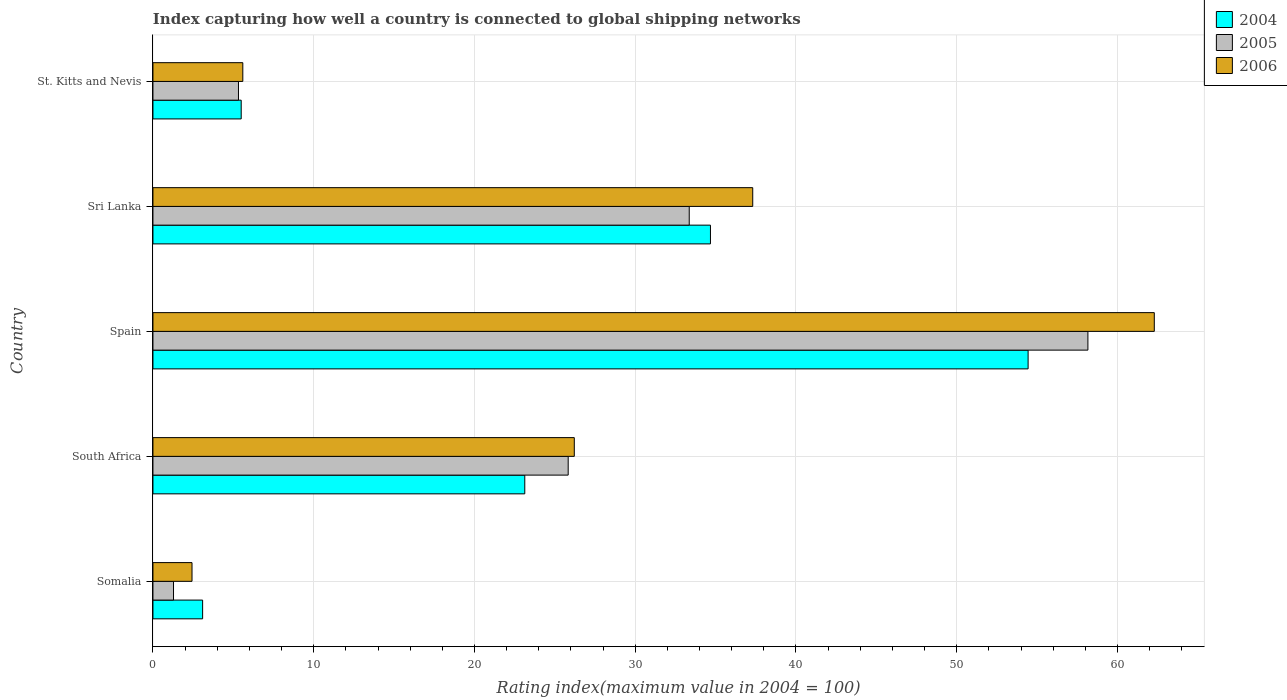Are the number of bars on each tick of the Y-axis equal?
Your response must be concise. Yes. What is the label of the 5th group of bars from the top?
Your response must be concise. Somalia. What is the rating index in 2006 in St. Kitts and Nevis?
Your answer should be very brief. 5.59. Across all countries, what is the maximum rating index in 2006?
Provide a short and direct response. 62.29. Across all countries, what is the minimum rating index in 2005?
Provide a short and direct response. 1.28. In which country was the rating index in 2006 minimum?
Your answer should be very brief. Somalia. What is the total rating index in 2005 in the graph?
Make the answer very short. 123.95. What is the difference between the rating index in 2005 in Spain and that in St. Kitts and Nevis?
Give a very brief answer. 52.84. What is the difference between the rating index in 2004 in Sri Lanka and the rating index in 2006 in South Africa?
Keep it short and to the point. 8.47. What is the average rating index in 2005 per country?
Your answer should be very brief. 24.79. What is the difference between the rating index in 2004 and rating index in 2005 in St. Kitts and Nevis?
Ensure brevity in your answer.  0.17. What is the ratio of the rating index in 2006 in South Africa to that in Sri Lanka?
Ensure brevity in your answer.  0.7. Is the rating index in 2004 in Spain less than that in Sri Lanka?
Offer a very short reply. No. What is the difference between the highest and the second highest rating index in 2004?
Offer a very short reply. 19.76. What is the difference between the highest and the lowest rating index in 2006?
Provide a short and direct response. 59.86. What does the 3rd bar from the top in South Africa represents?
Your answer should be very brief. 2004. How many bars are there?
Your answer should be very brief. 15. Are all the bars in the graph horizontal?
Your response must be concise. Yes. How many legend labels are there?
Offer a terse response. 3. How are the legend labels stacked?
Your answer should be very brief. Vertical. What is the title of the graph?
Your answer should be very brief. Index capturing how well a country is connected to global shipping networks. Does "1969" appear as one of the legend labels in the graph?
Ensure brevity in your answer.  No. What is the label or title of the X-axis?
Make the answer very short. Rating index(maximum value in 2004 = 100). What is the Rating index(maximum value in 2004 = 100) in 2004 in Somalia?
Your response must be concise. 3.09. What is the Rating index(maximum value in 2004 = 100) in 2005 in Somalia?
Ensure brevity in your answer.  1.28. What is the Rating index(maximum value in 2004 = 100) in 2006 in Somalia?
Give a very brief answer. 2.43. What is the Rating index(maximum value in 2004 = 100) of 2004 in South Africa?
Make the answer very short. 23.13. What is the Rating index(maximum value in 2004 = 100) in 2005 in South Africa?
Your response must be concise. 25.83. What is the Rating index(maximum value in 2004 = 100) in 2006 in South Africa?
Offer a terse response. 26.21. What is the Rating index(maximum value in 2004 = 100) of 2004 in Spain?
Give a very brief answer. 54.44. What is the Rating index(maximum value in 2004 = 100) of 2005 in Spain?
Your answer should be very brief. 58.16. What is the Rating index(maximum value in 2004 = 100) in 2006 in Spain?
Ensure brevity in your answer.  62.29. What is the Rating index(maximum value in 2004 = 100) of 2004 in Sri Lanka?
Your answer should be very brief. 34.68. What is the Rating index(maximum value in 2004 = 100) of 2005 in Sri Lanka?
Make the answer very short. 33.36. What is the Rating index(maximum value in 2004 = 100) in 2006 in Sri Lanka?
Ensure brevity in your answer.  37.31. What is the Rating index(maximum value in 2004 = 100) of 2004 in St. Kitts and Nevis?
Provide a succinct answer. 5.49. What is the Rating index(maximum value in 2004 = 100) of 2005 in St. Kitts and Nevis?
Your response must be concise. 5.32. What is the Rating index(maximum value in 2004 = 100) in 2006 in St. Kitts and Nevis?
Give a very brief answer. 5.59. Across all countries, what is the maximum Rating index(maximum value in 2004 = 100) in 2004?
Ensure brevity in your answer.  54.44. Across all countries, what is the maximum Rating index(maximum value in 2004 = 100) in 2005?
Your answer should be compact. 58.16. Across all countries, what is the maximum Rating index(maximum value in 2004 = 100) in 2006?
Your answer should be compact. 62.29. Across all countries, what is the minimum Rating index(maximum value in 2004 = 100) in 2004?
Offer a terse response. 3.09. Across all countries, what is the minimum Rating index(maximum value in 2004 = 100) in 2005?
Offer a very short reply. 1.28. Across all countries, what is the minimum Rating index(maximum value in 2004 = 100) in 2006?
Ensure brevity in your answer.  2.43. What is the total Rating index(maximum value in 2004 = 100) in 2004 in the graph?
Your answer should be very brief. 120.83. What is the total Rating index(maximum value in 2004 = 100) in 2005 in the graph?
Provide a succinct answer. 123.95. What is the total Rating index(maximum value in 2004 = 100) of 2006 in the graph?
Your answer should be compact. 133.83. What is the difference between the Rating index(maximum value in 2004 = 100) in 2004 in Somalia and that in South Africa?
Make the answer very short. -20.04. What is the difference between the Rating index(maximum value in 2004 = 100) of 2005 in Somalia and that in South Africa?
Provide a succinct answer. -24.55. What is the difference between the Rating index(maximum value in 2004 = 100) of 2006 in Somalia and that in South Africa?
Provide a succinct answer. -23.78. What is the difference between the Rating index(maximum value in 2004 = 100) in 2004 in Somalia and that in Spain?
Your response must be concise. -51.35. What is the difference between the Rating index(maximum value in 2004 = 100) in 2005 in Somalia and that in Spain?
Your answer should be compact. -56.88. What is the difference between the Rating index(maximum value in 2004 = 100) in 2006 in Somalia and that in Spain?
Offer a very short reply. -59.86. What is the difference between the Rating index(maximum value in 2004 = 100) in 2004 in Somalia and that in Sri Lanka?
Give a very brief answer. -31.59. What is the difference between the Rating index(maximum value in 2004 = 100) of 2005 in Somalia and that in Sri Lanka?
Offer a terse response. -32.08. What is the difference between the Rating index(maximum value in 2004 = 100) of 2006 in Somalia and that in Sri Lanka?
Your answer should be compact. -34.88. What is the difference between the Rating index(maximum value in 2004 = 100) in 2005 in Somalia and that in St. Kitts and Nevis?
Your answer should be compact. -4.04. What is the difference between the Rating index(maximum value in 2004 = 100) in 2006 in Somalia and that in St. Kitts and Nevis?
Offer a terse response. -3.16. What is the difference between the Rating index(maximum value in 2004 = 100) of 2004 in South Africa and that in Spain?
Your answer should be compact. -31.31. What is the difference between the Rating index(maximum value in 2004 = 100) in 2005 in South Africa and that in Spain?
Give a very brief answer. -32.33. What is the difference between the Rating index(maximum value in 2004 = 100) of 2006 in South Africa and that in Spain?
Offer a very short reply. -36.08. What is the difference between the Rating index(maximum value in 2004 = 100) of 2004 in South Africa and that in Sri Lanka?
Offer a terse response. -11.55. What is the difference between the Rating index(maximum value in 2004 = 100) of 2005 in South Africa and that in Sri Lanka?
Ensure brevity in your answer.  -7.53. What is the difference between the Rating index(maximum value in 2004 = 100) in 2006 in South Africa and that in Sri Lanka?
Your response must be concise. -11.1. What is the difference between the Rating index(maximum value in 2004 = 100) in 2004 in South Africa and that in St. Kitts and Nevis?
Make the answer very short. 17.64. What is the difference between the Rating index(maximum value in 2004 = 100) of 2005 in South Africa and that in St. Kitts and Nevis?
Your answer should be very brief. 20.51. What is the difference between the Rating index(maximum value in 2004 = 100) in 2006 in South Africa and that in St. Kitts and Nevis?
Offer a terse response. 20.62. What is the difference between the Rating index(maximum value in 2004 = 100) of 2004 in Spain and that in Sri Lanka?
Offer a terse response. 19.76. What is the difference between the Rating index(maximum value in 2004 = 100) in 2005 in Spain and that in Sri Lanka?
Offer a very short reply. 24.8. What is the difference between the Rating index(maximum value in 2004 = 100) of 2006 in Spain and that in Sri Lanka?
Offer a very short reply. 24.98. What is the difference between the Rating index(maximum value in 2004 = 100) in 2004 in Spain and that in St. Kitts and Nevis?
Keep it short and to the point. 48.95. What is the difference between the Rating index(maximum value in 2004 = 100) in 2005 in Spain and that in St. Kitts and Nevis?
Give a very brief answer. 52.84. What is the difference between the Rating index(maximum value in 2004 = 100) in 2006 in Spain and that in St. Kitts and Nevis?
Give a very brief answer. 56.7. What is the difference between the Rating index(maximum value in 2004 = 100) in 2004 in Sri Lanka and that in St. Kitts and Nevis?
Offer a very short reply. 29.19. What is the difference between the Rating index(maximum value in 2004 = 100) of 2005 in Sri Lanka and that in St. Kitts and Nevis?
Provide a succinct answer. 28.04. What is the difference between the Rating index(maximum value in 2004 = 100) in 2006 in Sri Lanka and that in St. Kitts and Nevis?
Give a very brief answer. 31.72. What is the difference between the Rating index(maximum value in 2004 = 100) in 2004 in Somalia and the Rating index(maximum value in 2004 = 100) in 2005 in South Africa?
Provide a succinct answer. -22.74. What is the difference between the Rating index(maximum value in 2004 = 100) of 2004 in Somalia and the Rating index(maximum value in 2004 = 100) of 2006 in South Africa?
Your answer should be compact. -23.12. What is the difference between the Rating index(maximum value in 2004 = 100) in 2005 in Somalia and the Rating index(maximum value in 2004 = 100) in 2006 in South Africa?
Your answer should be very brief. -24.93. What is the difference between the Rating index(maximum value in 2004 = 100) in 2004 in Somalia and the Rating index(maximum value in 2004 = 100) in 2005 in Spain?
Ensure brevity in your answer.  -55.07. What is the difference between the Rating index(maximum value in 2004 = 100) in 2004 in Somalia and the Rating index(maximum value in 2004 = 100) in 2006 in Spain?
Give a very brief answer. -59.2. What is the difference between the Rating index(maximum value in 2004 = 100) in 2005 in Somalia and the Rating index(maximum value in 2004 = 100) in 2006 in Spain?
Keep it short and to the point. -61.01. What is the difference between the Rating index(maximum value in 2004 = 100) in 2004 in Somalia and the Rating index(maximum value in 2004 = 100) in 2005 in Sri Lanka?
Provide a short and direct response. -30.27. What is the difference between the Rating index(maximum value in 2004 = 100) in 2004 in Somalia and the Rating index(maximum value in 2004 = 100) in 2006 in Sri Lanka?
Your answer should be compact. -34.22. What is the difference between the Rating index(maximum value in 2004 = 100) in 2005 in Somalia and the Rating index(maximum value in 2004 = 100) in 2006 in Sri Lanka?
Provide a succinct answer. -36.03. What is the difference between the Rating index(maximum value in 2004 = 100) in 2004 in Somalia and the Rating index(maximum value in 2004 = 100) in 2005 in St. Kitts and Nevis?
Your answer should be very brief. -2.23. What is the difference between the Rating index(maximum value in 2004 = 100) in 2005 in Somalia and the Rating index(maximum value in 2004 = 100) in 2006 in St. Kitts and Nevis?
Keep it short and to the point. -4.31. What is the difference between the Rating index(maximum value in 2004 = 100) of 2004 in South Africa and the Rating index(maximum value in 2004 = 100) of 2005 in Spain?
Your answer should be compact. -35.03. What is the difference between the Rating index(maximum value in 2004 = 100) of 2004 in South Africa and the Rating index(maximum value in 2004 = 100) of 2006 in Spain?
Your response must be concise. -39.16. What is the difference between the Rating index(maximum value in 2004 = 100) of 2005 in South Africa and the Rating index(maximum value in 2004 = 100) of 2006 in Spain?
Offer a very short reply. -36.46. What is the difference between the Rating index(maximum value in 2004 = 100) of 2004 in South Africa and the Rating index(maximum value in 2004 = 100) of 2005 in Sri Lanka?
Offer a terse response. -10.23. What is the difference between the Rating index(maximum value in 2004 = 100) in 2004 in South Africa and the Rating index(maximum value in 2004 = 100) in 2006 in Sri Lanka?
Ensure brevity in your answer.  -14.18. What is the difference between the Rating index(maximum value in 2004 = 100) of 2005 in South Africa and the Rating index(maximum value in 2004 = 100) of 2006 in Sri Lanka?
Ensure brevity in your answer.  -11.48. What is the difference between the Rating index(maximum value in 2004 = 100) in 2004 in South Africa and the Rating index(maximum value in 2004 = 100) in 2005 in St. Kitts and Nevis?
Your response must be concise. 17.81. What is the difference between the Rating index(maximum value in 2004 = 100) of 2004 in South Africa and the Rating index(maximum value in 2004 = 100) of 2006 in St. Kitts and Nevis?
Your answer should be very brief. 17.54. What is the difference between the Rating index(maximum value in 2004 = 100) in 2005 in South Africa and the Rating index(maximum value in 2004 = 100) in 2006 in St. Kitts and Nevis?
Make the answer very short. 20.24. What is the difference between the Rating index(maximum value in 2004 = 100) in 2004 in Spain and the Rating index(maximum value in 2004 = 100) in 2005 in Sri Lanka?
Offer a very short reply. 21.08. What is the difference between the Rating index(maximum value in 2004 = 100) in 2004 in Spain and the Rating index(maximum value in 2004 = 100) in 2006 in Sri Lanka?
Offer a terse response. 17.13. What is the difference between the Rating index(maximum value in 2004 = 100) in 2005 in Spain and the Rating index(maximum value in 2004 = 100) in 2006 in Sri Lanka?
Offer a very short reply. 20.85. What is the difference between the Rating index(maximum value in 2004 = 100) in 2004 in Spain and the Rating index(maximum value in 2004 = 100) in 2005 in St. Kitts and Nevis?
Offer a terse response. 49.12. What is the difference between the Rating index(maximum value in 2004 = 100) of 2004 in Spain and the Rating index(maximum value in 2004 = 100) of 2006 in St. Kitts and Nevis?
Offer a terse response. 48.85. What is the difference between the Rating index(maximum value in 2004 = 100) in 2005 in Spain and the Rating index(maximum value in 2004 = 100) in 2006 in St. Kitts and Nevis?
Provide a succinct answer. 52.57. What is the difference between the Rating index(maximum value in 2004 = 100) in 2004 in Sri Lanka and the Rating index(maximum value in 2004 = 100) in 2005 in St. Kitts and Nevis?
Keep it short and to the point. 29.36. What is the difference between the Rating index(maximum value in 2004 = 100) of 2004 in Sri Lanka and the Rating index(maximum value in 2004 = 100) of 2006 in St. Kitts and Nevis?
Make the answer very short. 29.09. What is the difference between the Rating index(maximum value in 2004 = 100) in 2005 in Sri Lanka and the Rating index(maximum value in 2004 = 100) in 2006 in St. Kitts and Nevis?
Provide a succinct answer. 27.77. What is the average Rating index(maximum value in 2004 = 100) in 2004 per country?
Your answer should be very brief. 24.17. What is the average Rating index(maximum value in 2004 = 100) in 2005 per country?
Your response must be concise. 24.79. What is the average Rating index(maximum value in 2004 = 100) of 2006 per country?
Your answer should be very brief. 26.77. What is the difference between the Rating index(maximum value in 2004 = 100) of 2004 and Rating index(maximum value in 2004 = 100) of 2005 in Somalia?
Give a very brief answer. 1.81. What is the difference between the Rating index(maximum value in 2004 = 100) in 2004 and Rating index(maximum value in 2004 = 100) in 2006 in Somalia?
Make the answer very short. 0.66. What is the difference between the Rating index(maximum value in 2004 = 100) in 2005 and Rating index(maximum value in 2004 = 100) in 2006 in Somalia?
Give a very brief answer. -1.15. What is the difference between the Rating index(maximum value in 2004 = 100) in 2004 and Rating index(maximum value in 2004 = 100) in 2005 in South Africa?
Provide a succinct answer. -2.7. What is the difference between the Rating index(maximum value in 2004 = 100) in 2004 and Rating index(maximum value in 2004 = 100) in 2006 in South Africa?
Your answer should be compact. -3.08. What is the difference between the Rating index(maximum value in 2004 = 100) of 2005 and Rating index(maximum value in 2004 = 100) of 2006 in South Africa?
Provide a succinct answer. -0.38. What is the difference between the Rating index(maximum value in 2004 = 100) in 2004 and Rating index(maximum value in 2004 = 100) in 2005 in Spain?
Keep it short and to the point. -3.72. What is the difference between the Rating index(maximum value in 2004 = 100) in 2004 and Rating index(maximum value in 2004 = 100) in 2006 in Spain?
Offer a very short reply. -7.85. What is the difference between the Rating index(maximum value in 2004 = 100) in 2005 and Rating index(maximum value in 2004 = 100) in 2006 in Spain?
Your answer should be very brief. -4.13. What is the difference between the Rating index(maximum value in 2004 = 100) of 2004 and Rating index(maximum value in 2004 = 100) of 2005 in Sri Lanka?
Provide a succinct answer. 1.32. What is the difference between the Rating index(maximum value in 2004 = 100) of 2004 and Rating index(maximum value in 2004 = 100) of 2006 in Sri Lanka?
Your answer should be compact. -2.63. What is the difference between the Rating index(maximum value in 2004 = 100) of 2005 and Rating index(maximum value in 2004 = 100) of 2006 in Sri Lanka?
Your response must be concise. -3.95. What is the difference between the Rating index(maximum value in 2004 = 100) in 2004 and Rating index(maximum value in 2004 = 100) in 2005 in St. Kitts and Nevis?
Ensure brevity in your answer.  0.17. What is the difference between the Rating index(maximum value in 2004 = 100) of 2004 and Rating index(maximum value in 2004 = 100) of 2006 in St. Kitts and Nevis?
Your answer should be very brief. -0.1. What is the difference between the Rating index(maximum value in 2004 = 100) of 2005 and Rating index(maximum value in 2004 = 100) of 2006 in St. Kitts and Nevis?
Keep it short and to the point. -0.27. What is the ratio of the Rating index(maximum value in 2004 = 100) of 2004 in Somalia to that in South Africa?
Provide a succinct answer. 0.13. What is the ratio of the Rating index(maximum value in 2004 = 100) in 2005 in Somalia to that in South Africa?
Make the answer very short. 0.05. What is the ratio of the Rating index(maximum value in 2004 = 100) of 2006 in Somalia to that in South Africa?
Offer a very short reply. 0.09. What is the ratio of the Rating index(maximum value in 2004 = 100) in 2004 in Somalia to that in Spain?
Ensure brevity in your answer.  0.06. What is the ratio of the Rating index(maximum value in 2004 = 100) of 2005 in Somalia to that in Spain?
Provide a succinct answer. 0.02. What is the ratio of the Rating index(maximum value in 2004 = 100) of 2006 in Somalia to that in Spain?
Provide a short and direct response. 0.04. What is the ratio of the Rating index(maximum value in 2004 = 100) of 2004 in Somalia to that in Sri Lanka?
Your answer should be very brief. 0.09. What is the ratio of the Rating index(maximum value in 2004 = 100) of 2005 in Somalia to that in Sri Lanka?
Keep it short and to the point. 0.04. What is the ratio of the Rating index(maximum value in 2004 = 100) of 2006 in Somalia to that in Sri Lanka?
Your answer should be compact. 0.07. What is the ratio of the Rating index(maximum value in 2004 = 100) of 2004 in Somalia to that in St. Kitts and Nevis?
Your answer should be very brief. 0.56. What is the ratio of the Rating index(maximum value in 2004 = 100) of 2005 in Somalia to that in St. Kitts and Nevis?
Your answer should be compact. 0.24. What is the ratio of the Rating index(maximum value in 2004 = 100) of 2006 in Somalia to that in St. Kitts and Nevis?
Your response must be concise. 0.43. What is the ratio of the Rating index(maximum value in 2004 = 100) in 2004 in South Africa to that in Spain?
Offer a terse response. 0.42. What is the ratio of the Rating index(maximum value in 2004 = 100) in 2005 in South Africa to that in Spain?
Give a very brief answer. 0.44. What is the ratio of the Rating index(maximum value in 2004 = 100) of 2006 in South Africa to that in Spain?
Make the answer very short. 0.42. What is the ratio of the Rating index(maximum value in 2004 = 100) in 2004 in South Africa to that in Sri Lanka?
Ensure brevity in your answer.  0.67. What is the ratio of the Rating index(maximum value in 2004 = 100) in 2005 in South Africa to that in Sri Lanka?
Offer a very short reply. 0.77. What is the ratio of the Rating index(maximum value in 2004 = 100) in 2006 in South Africa to that in Sri Lanka?
Keep it short and to the point. 0.7. What is the ratio of the Rating index(maximum value in 2004 = 100) in 2004 in South Africa to that in St. Kitts and Nevis?
Keep it short and to the point. 4.21. What is the ratio of the Rating index(maximum value in 2004 = 100) in 2005 in South Africa to that in St. Kitts and Nevis?
Your answer should be compact. 4.86. What is the ratio of the Rating index(maximum value in 2004 = 100) of 2006 in South Africa to that in St. Kitts and Nevis?
Provide a short and direct response. 4.69. What is the ratio of the Rating index(maximum value in 2004 = 100) of 2004 in Spain to that in Sri Lanka?
Make the answer very short. 1.57. What is the ratio of the Rating index(maximum value in 2004 = 100) in 2005 in Spain to that in Sri Lanka?
Provide a succinct answer. 1.74. What is the ratio of the Rating index(maximum value in 2004 = 100) of 2006 in Spain to that in Sri Lanka?
Your answer should be compact. 1.67. What is the ratio of the Rating index(maximum value in 2004 = 100) of 2004 in Spain to that in St. Kitts and Nevis?
Give a very brief answer. 9.92. What is the ratio of the Rating index(maximum value in 2004 = 100) in 2005 in Spain to that in St. Kitts and Nevis?
Offer a terse response. 10.93. What is the ratio of the Rating index(maximum value in 2004 = 100) in 2006 in Spain to that in St. Kitts and Nevis?
Your response must be concise. 11.14. What is the ratio of the Rating index(maximum value in 2004 = 100) of 2004 in Sri Lanka to that in St. Kitts and Nevis?
Ensure brevity in your answer.  6.32. What is the ratio of the Rating index(maximum value in 2004 = 100) of 2005 in Sri Lanka to that in St. Kitts and Nevis?
Your response must be concise. 6.27. What is the ratio of the Rating index(maximum value in 2004 = 100) in 2006 in Sri Lanka to that in St. Kitts and Nevis?
Provide a short and direct response. 6.67. What is the difference between the highest and the second highest Rating index(maximum value in 2004 = 100) in 2004?
Your response must be concise. 19.76. What is the difference between the highest and the second highest Rating index(maximum value in 2004 = 100) in 2005?
Give a very brief answer. 24.8. What is the difference between the highest and the second highest Rating index(maximum value in 2004 = 100) in 2006?
Your answer should be very brief. 24.98. What is the difference between the highest and the lowest Rating index(maximum value in 2004 = 100) in 2004?
Keep it short and to the point. 51.35. What is the difference between the highest and the lowest Rating index(maximum value in 2004 = 100) in 2005?
Ensure brevity in your answer.  56.88. What is the difference between the highest and the lowest Rating index(maximum value in 2004 = 100) in 2006?
Keep it short and to the point. 59.86. 